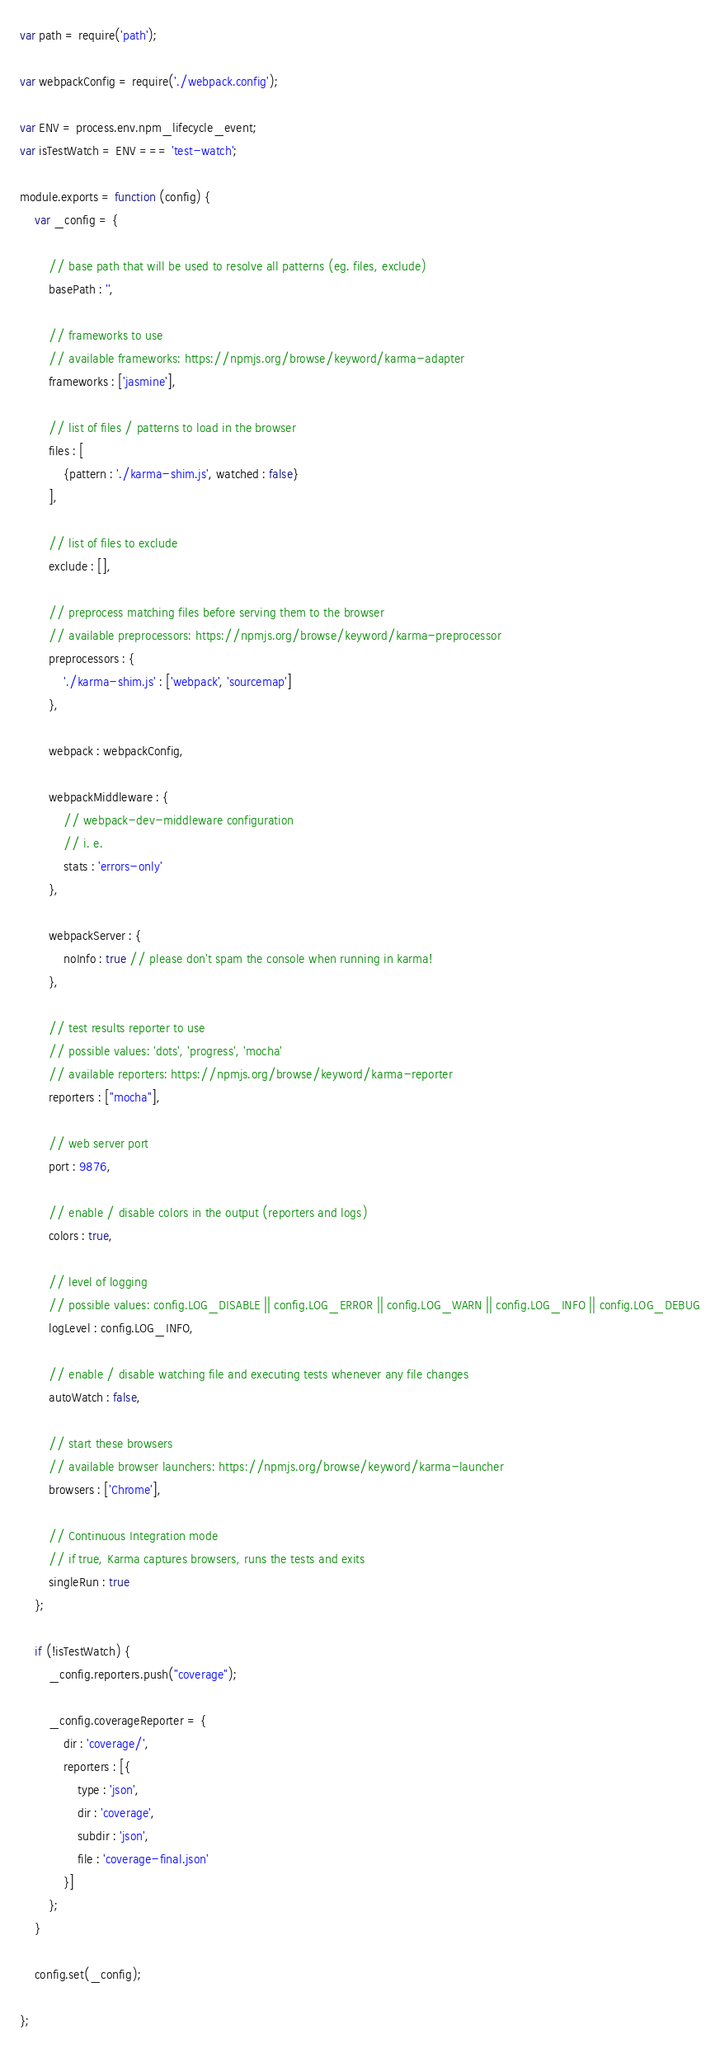<code> <loc_0><loc_0><loc_500><loc_500><_JavaScript_>var path = require('path');

var webpackConfig = require('./webpack.config');

var ENV = process.env.npm_lifecycle_event;
var isTestWatch = ENV === 'test-watch';

module.exports = function (config) {
    var _config = {

        // base path that will be used to resolve all patterns (eg. files, exclude)
        basePath : '',

        // frameworks to use
        // available frameworks: https://npmjs.org/browse/keyword/karma-adapter
        frameworks : ['jasmine'],

        // list of files / patterns to load in the browser
        files : [
            {pattern : './karma-shim.js', watched : false}
        ],

        // list of files to exclude
        exclude : [],

        // preprocess matching files before serving them to the browser
        // available preprocessors: https://npmjs.org/browse/keyword/karma-preprocessor
        preprocessors : {
            './karma-shim.js' : ['webpack', 'sourcemap']
        },

        webpack : webpackConfig,

        webpackMiddleware : {
            // webpack-dev-middleware configuration
            // i. e.
            stats : 'errors-only'
        },

        webpackServer : {
            noInfo : true // please don't spam the console when running in karma!
        },

        // test results reporter to use
        // possible values: 'dots', 'progress', 'mocha'
        // available reporters: https://npmjs.org/browse/keyword/karma-reporter
        reporters : ["mocha"],

        // web server port
        port : 9876,

        // enable / disable colors in the output (reporters and logs)
        colors : true,

        // level of logging
        // possible values: config.LOG_DISABLE || config.LOG_ERROR || config.LOG_WARN || config.LOG_INFO || config.LOG_DEBUG
        logLevel : config.LOG_INFO,

        // enable / disable watching file and executing tests whenever any file changes
        autoWatch : false,

        // start these browsers
        // available browser launchers: https://npmjs.org/browse/keyword/karma-launcher
        browsers : ['Chrome'],

        // Continuous Integration mode
        // if true, Karma captures browsers, runs the tests and exits
        singleRun : true
    };

    if (!isTestWatch) {
        _config.reporters.push("coverage");

        _config.coverageReporter = {
            dir : 'coverage/',
            reporters : [{
                type : 'json',
                dir : 'coverage',
                subdir : 'json',
                file : 'coverage-final.json'
            }]
        };
    }

    config.set(_config);

};
</code> 